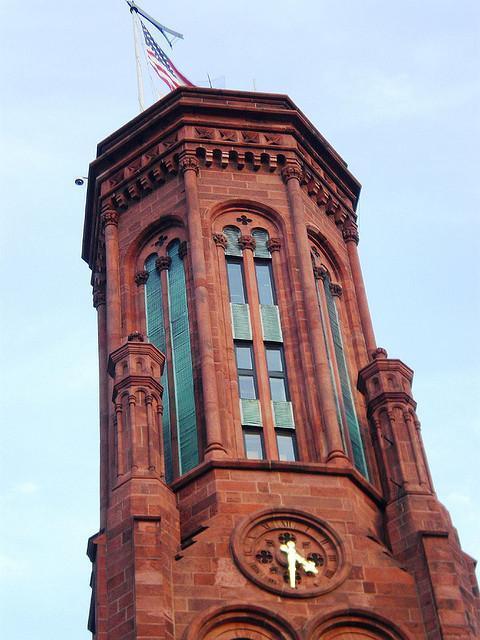How many people watch the surfers?
Give a very brief answer. 0. 